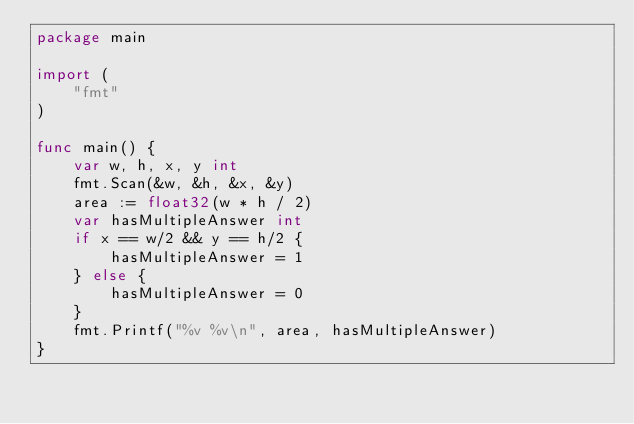Convert code to text. <code><loc_0><loc_0><loc_500><loc_500><_Go_>package main

import (
	"fmt"
)

func main() {
	var w, h, x, y int
	fmt.Scan(&w, &h, &x, &y)
	area := float32(w * h / 2)
	var hasMultipleAnswer int
	if x == w/2 && y == h/2 {
		hasMultipleAnswer = 1
	} else {
		hasMultipleAnswer = 0
	}
	fmt.Printf("%v %v\n", area, hasMultipleAnswer)
}
</code> 